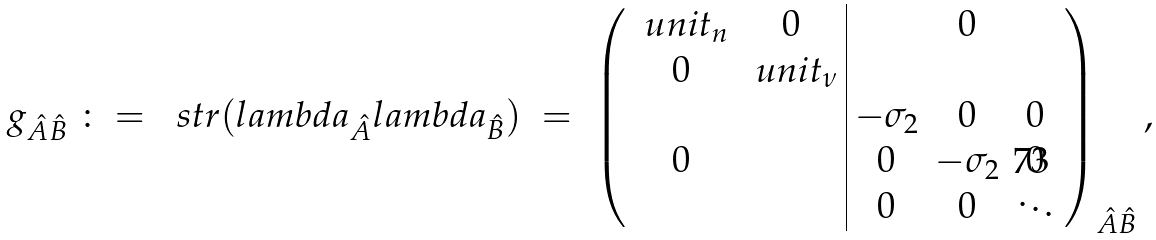<formula> <loc_0><loc_0><loc_500><loc_500>g _ { \hat { A } \hat { B } } \ \colon = \ \ s t r ( l a m b d a _ { \hat { A } } l a m b d a _ { \hat { B } } ) \ = \ \left ( \begin{array} { c c | c c c } \ u n i t _ { n } & 0 & & 0 & \\ 0 & \ u n i t _ { \nu } & & & \\ & & - \sigma _ { 2 } & 0 & 0 \\ 0 & & 0 & - \sigma _ { 2 } & 0 \\ & & 0 & 0 & \ddots \end{array} \right ) _ { \hat { A } \hat { B } } ,</formula> 